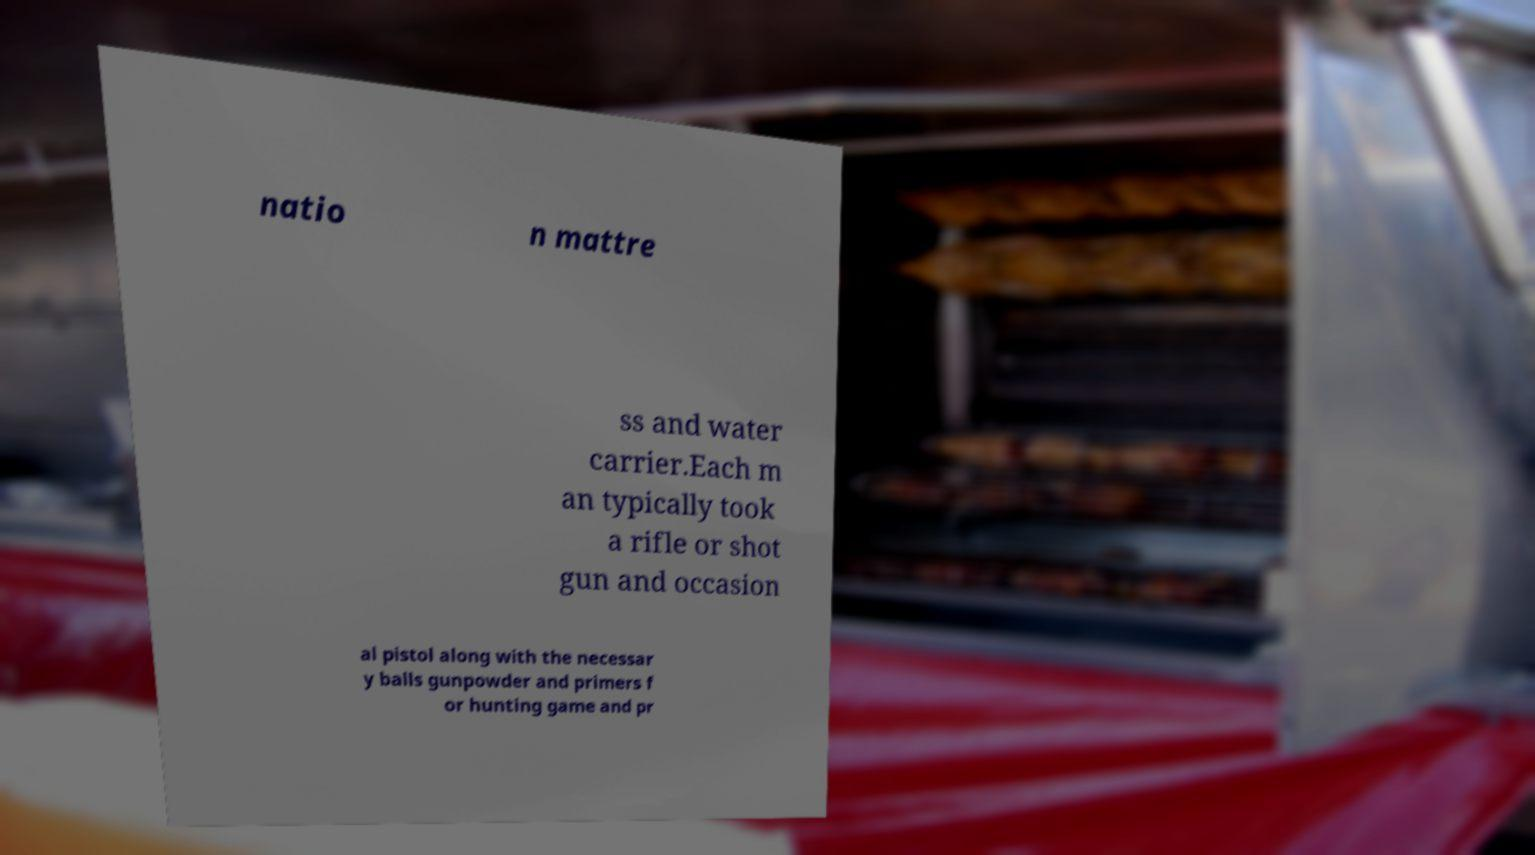Can you accurately transcribe the text from the provided image for me? natio n mattre ss and water carrier.Each m an typically took a rifle or shot gun and occasion al pistol along with the necessar y balls gunpowder and primers f or hunting game and pr 